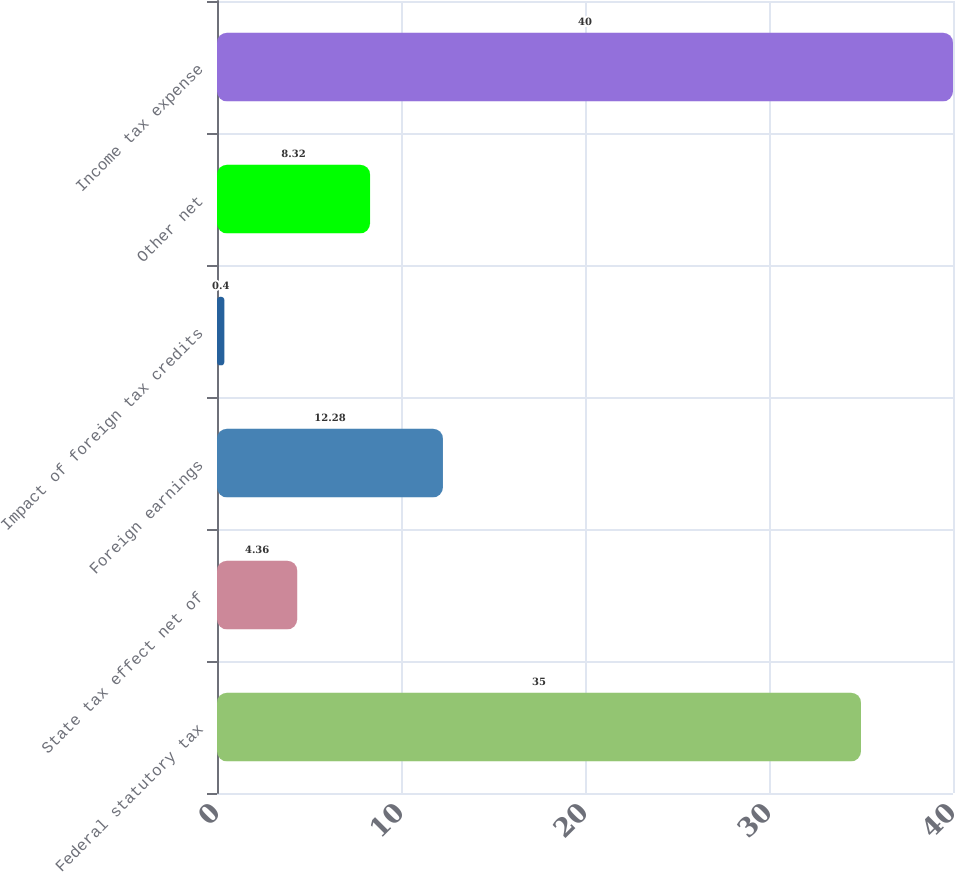<chart> <loc_0><loc_0><loc_500><loc_500><bar_chart><fcel>Federal statutory tax<fcel>State tax effect net of<fcel>Foreign earnings<fcel>Impact of foreign tax credits<fcel>Other net<fcel>Income tax expense<nl><fcel>35<fcel>4.36<fcel>12.28<fcel>0.4<fcel>8.32<fcel>40<nl></chart> 